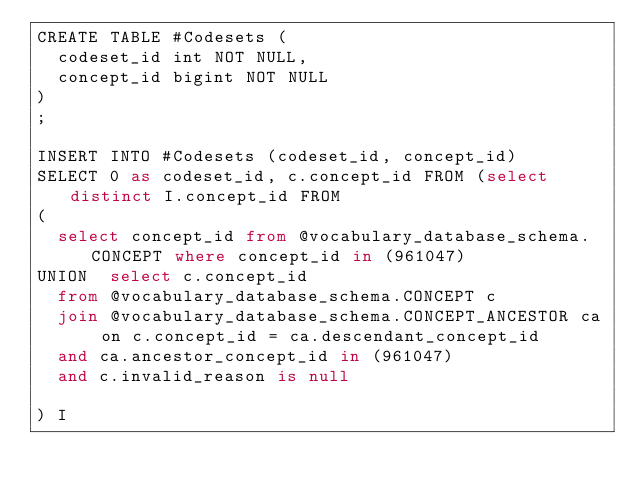<code> <loc_0><loc_0><loc_500><loc_500><_SQL_>CREATE TABLE #Codesets (
  codeset_id int NOT NULL,
  concept_id bigint NOT NULL
)
;

INSERT INTO #Codesets (codeset_id, concept_id)
SELECT 0 as codeset_id, c.concept_id FROM (select distinct I.concept_id FROM
(
  select concept_id from @vocabulary_database_schema.CONCEPT where concept_id in (961047)
UNION  select c.concept_id
  from @vocabulary_database_schema.CONCEPT c
  join @vocabulary_database_schema.CONCEPT_ANCESTOR ca on c.concept_id = ca.descendant_concept_id
  and ca.ancestor_concept_id in (961047)
  and c.invalid_reason is null

) I</code> 